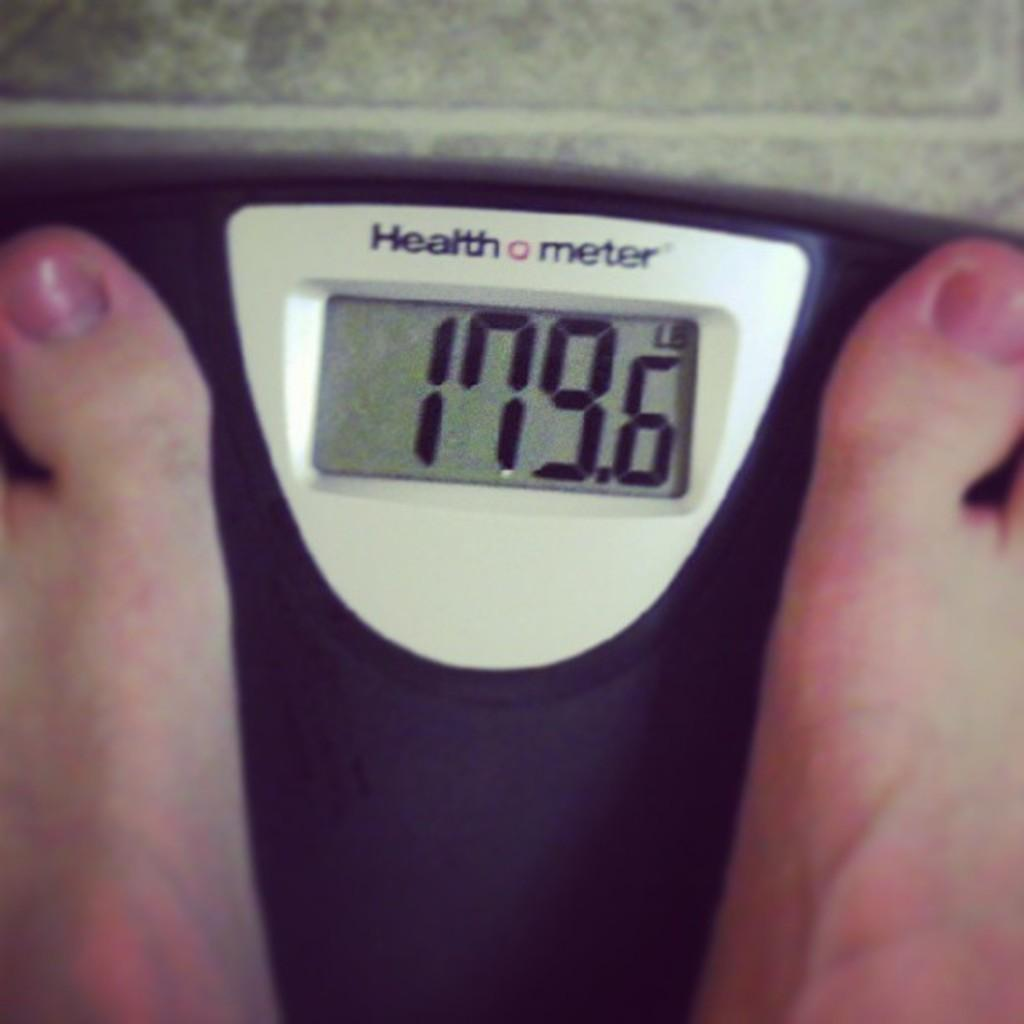<image>
Write a terse but informative summary of the picture. Person weighing themselves with a screen that says 179.6 